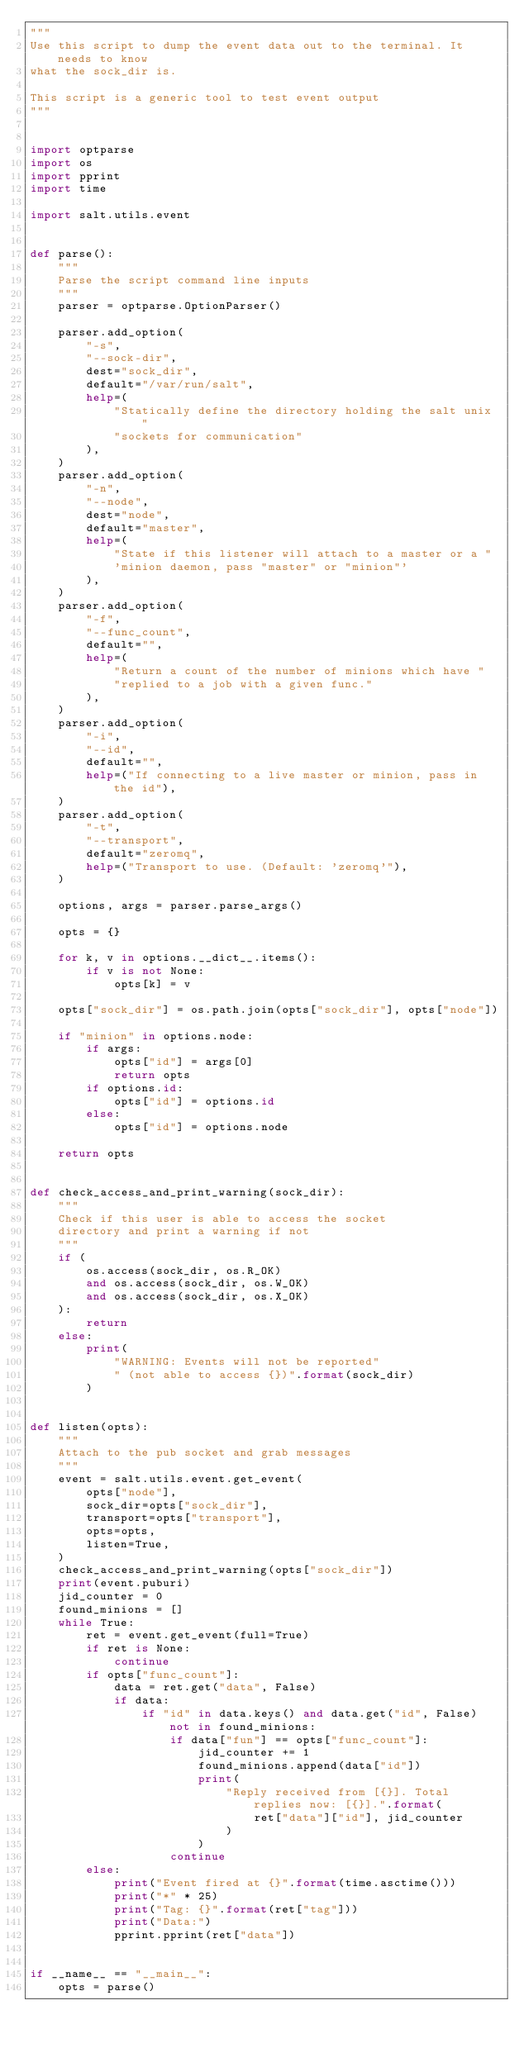Convert code to text. <code><loc_0><loc_0><loc_500><loc_500><_Python_>"""
Use this script to dump the event data out to the terminal. It needs to know
what the sock_dir is.

This script is a generic tool to test event output
"""


import optparse
import os
import pprint
import time

import salt.utils.event


def parse():
    """
    Parse the script command line inputs
    """
    parser = optparse.OptionParser()

    parser.add_option(
        "-s",
        "--sock-dir",
        dest="sock_dir",
        default="/var/run/salt",
        help=(
            "Statically define the directory holding the salt unix "
            "sockets for communication"
        ),
    )
    parser.add_option(
        "-n",
        "--node",
        dest="node",
        default="master",
        help=(
            "State if this listener will attach to a master or a "
            'minion daemon, pass "master" or "minion"'
        ),
    )
    parser.add_option(
        "-f",
        "--func_count",
        default="",
        help=(
            "Return a count of the number of minions which have "
            "replied to a job with a given func."
        ),
    )
    parser.add_option(
        "-i",
        "--id",
        default="",
        help=("If connecting to a live master or minion, pass in the id"),
    )
    parser.add_option(
        "-t",
        "--transport",
        default="zeromq",
        help=("Transport to use. (Default: 'zeromq'"),
    )

    options, args = parser.parse_args()

    opts = {}

    for k, v in options.__dict__.items():
        if v is not None:
            opts[k] = v

    opts["sock_dir"] = os.path.join(opts["sock_dir"], opts["node"])

    if "minion" in options.node:
        if args:
            opts["id"] = args[0]
            return opts
        if options.id:
            opts["id"] = options.id
        else:
            opts["id"] = options.node

    return opts


def check_access_and_print_warning(sock_dir):
    """
    Check if this user is able to access the socket
    directory and print a warning if not
    """
    if (
        os.access(sock_dir, os.R_OK)
        and os.access(sock_dir, os.W_OK)
        and os.access(sock_dir, os.X_OK)
    ):
        return
    else:
        print(
            "WARNING: Events will not be reported"
            " (not able to access {})".format(sock_dir)
        )


def listen(opts):
    """
    Attach to the pub socket and grab messages
    """
    event = salt.utils.event.get_event(
        opts["node"],
        sock_dir=opts["sock_dir"],
        transport=opts["transport"],
        opts=opts,
        listen=True,
    )
    check_access_and_print_warning(opts["sock_dir"])
    print(event.puburi)
    jid_counter = 0
    found_minions = []
    while True:
        ret = event.get_event(full=True)
        if ret is None:
            continue
        if opts["func_count"]:
            data = ret.get("data", False)
            if data:
                if "id" in data.keys() and data.get("id", False) not in found_minions:
                    if data["fun"] == opts["func_count"]:
                        jid_counter += 1
                        found_minions.append(data["id"])
                        print(
                            "Reply received from [{}]. Total replies now: [{}].".format(
                                ret["data"]["id"], jid_counter
                            )
                        )
                    continue
        else:
            print("Event fired at {}".format(time.asctime()))
            print("*" * 25)
            print("Tag: {}".format(ret["tag"]))
            print("Data:")
            pprint.pprint(ret["data"])


if __name__ == "__main__":
    opts = parse()</code> 